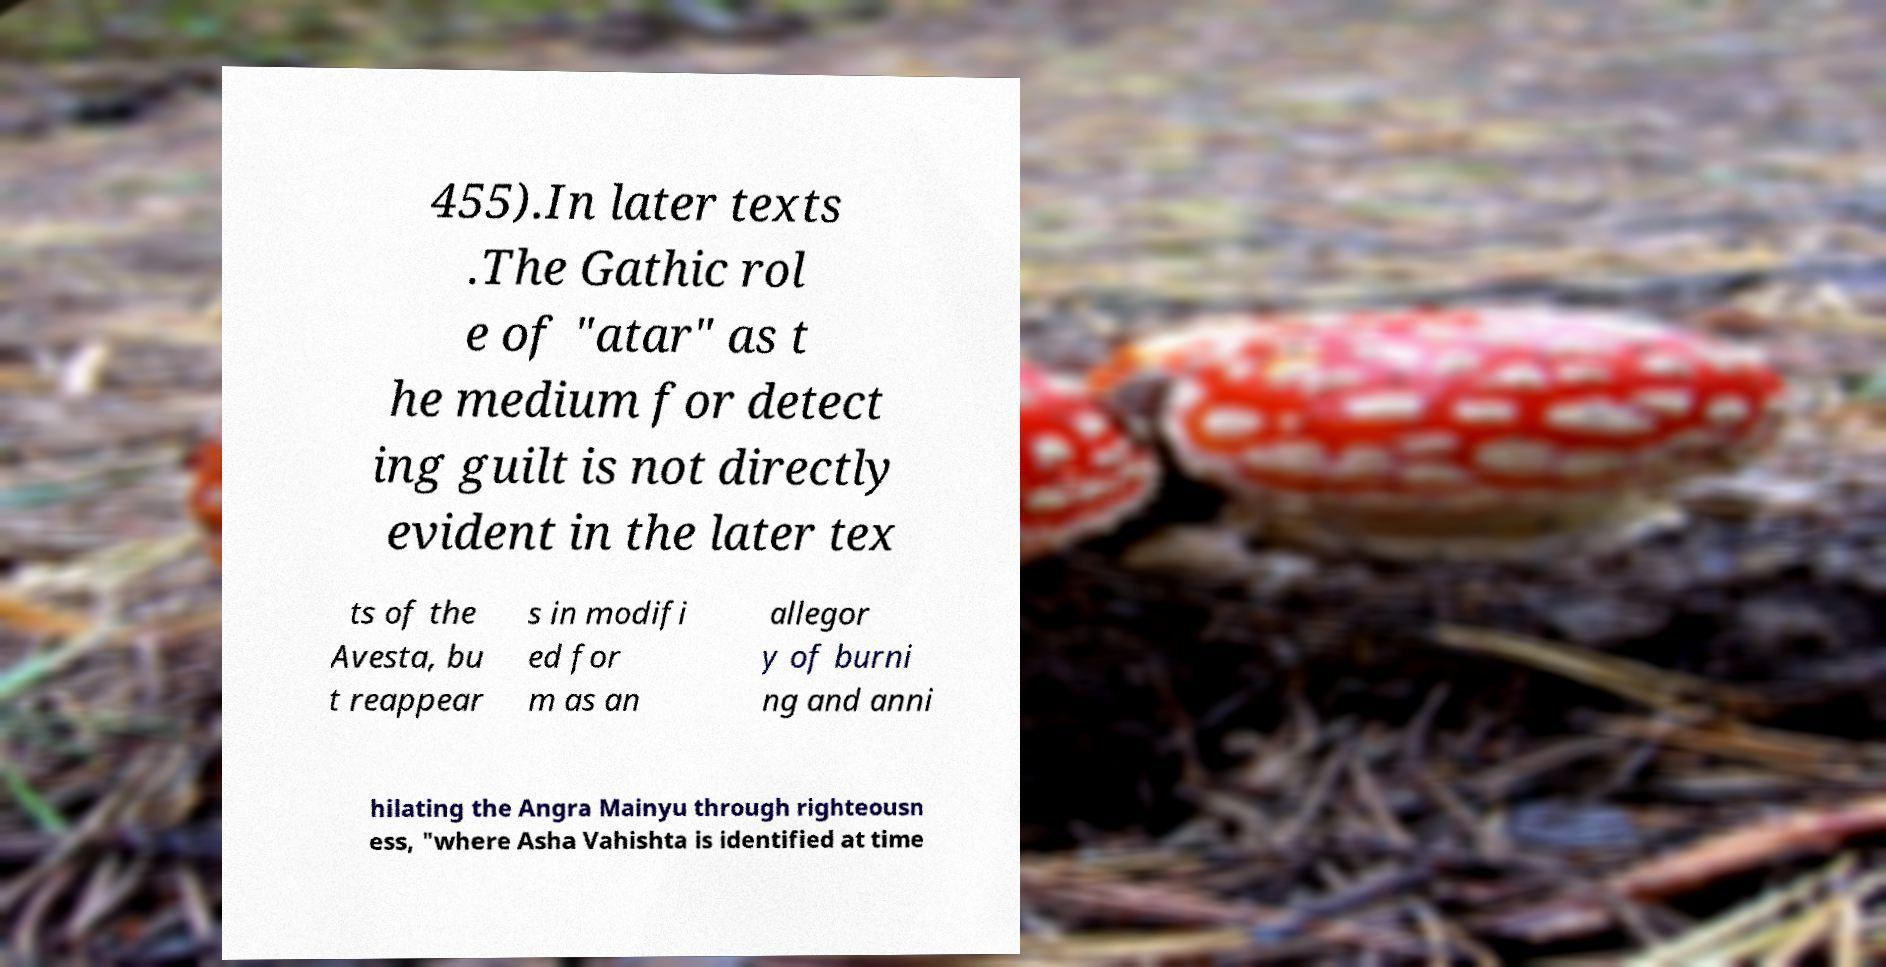Can you accurately transcribe the text from the provided image for me? 455).In later texts .The Gathic rol e of "atar" as t he medium for detect ing guilt is not directly evident in the later tex ts of the Avesta, bu t reappear s in modifi ed for m as an allegor y of burni ng and anni hilating the Angra Mainyu through righteousn ess, "where Asha Vahishta is identified at time 